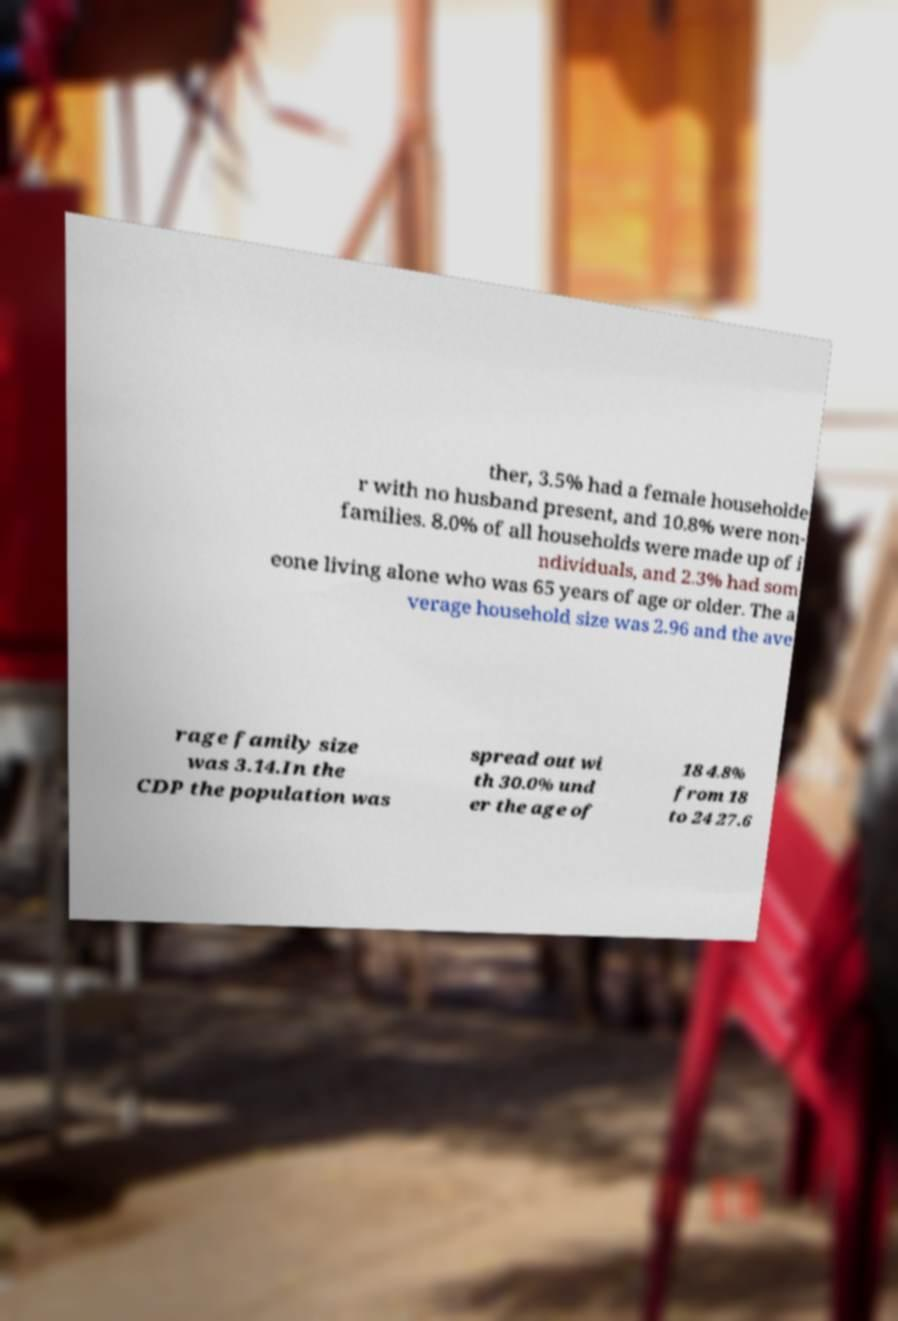For documentation purposes, I need the text within this image transcribed. Could you provide that? ther, 3.5% had a female householde r with no husband present, and 10.8% were non- families. 8.0% of all households were made up of i ndividuals, and 2.3% had som eone living alone who was 65 years of age or older. The a verage household size was 2.96 and the ave rage family size was 3.14.In the CDP the population was spread out wi th 30.0% und er the age of 18 4.8% from 18 to 24 27.6 